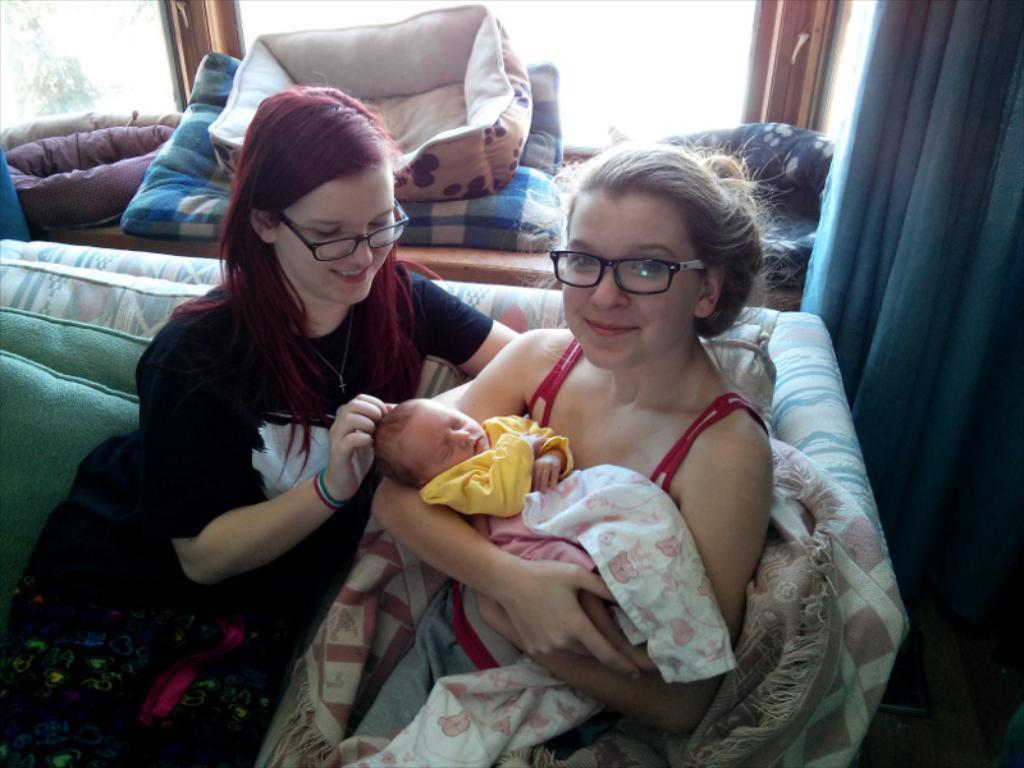How many people are in the image? There are two women in the image. What are the women doing in the image? The women are holding a kid in the image. Where are the women and the kid sitting? The women and the kid are sitting on a sofa in the image. What can be seen to the right in the image? There is a curtain to the right in the image. What is visible in the background of the image? There is a window and pillows in the background of the image. What type of beetle can be seen crawling on the sofa in the image? There is no beetle present in the image; the women and the kid are sitting on the sofa. What game are the women and the kid playing in the image? The image does not depict a game being played; the women are holding the kid while sitting on the sofa. 